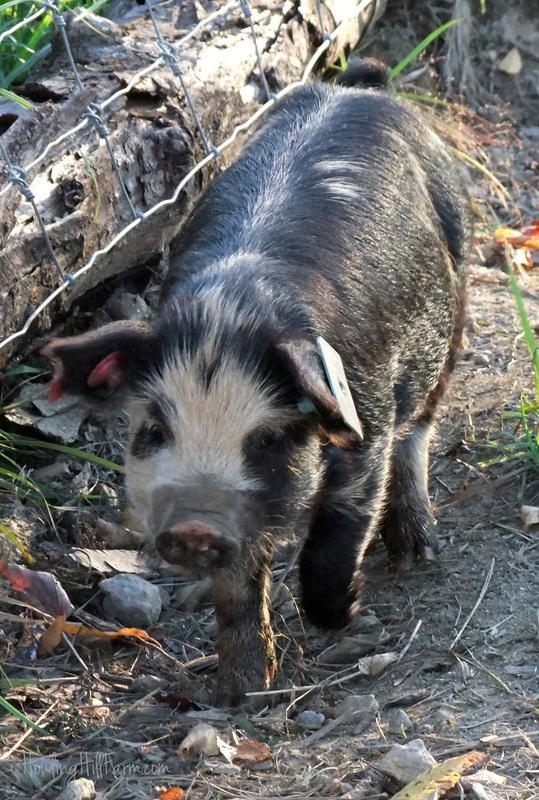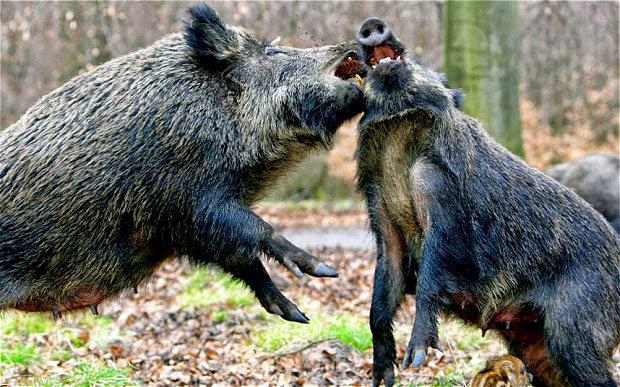The first image is the image on the left, the second image is the image on the right. Considering the images on both sides, is "An image contains exactly two pigs, which are striped juveniles." valid? Answer yes or no. No. The first image is the image on the left, the second image is the image on the right. Analyze the images presented: Is the assertion "At least one of the animals in the image on the right has its mouth open." valid? Answer yes or no. Yes. 